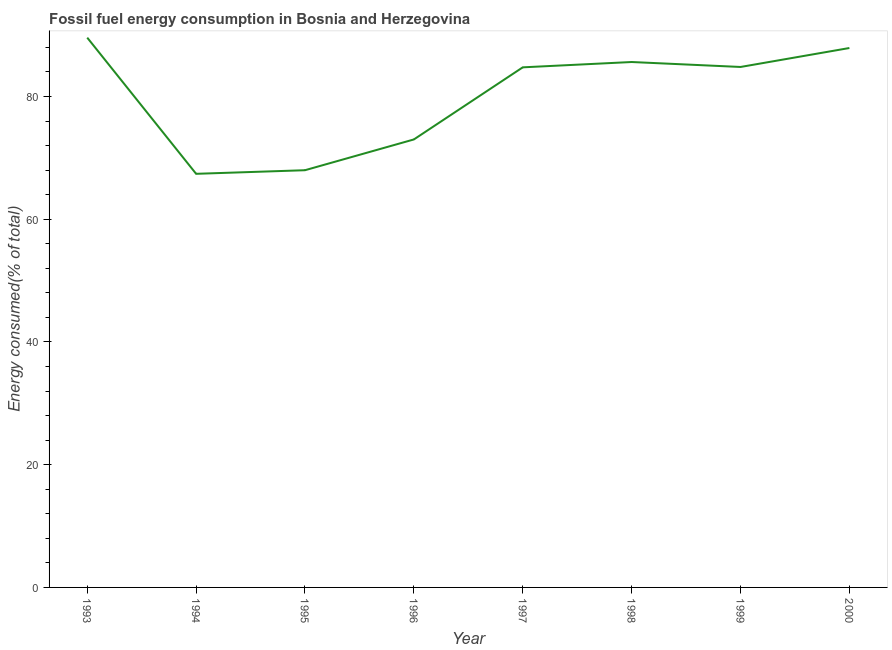What is the fossil fuel energy consumption in 2000?
Give a very brief answer. 87.89. Across all years, what is the maximum fossil fuel energy consumption?
Offer a very short reply. 89.58. Across all years, what is the minimum fossil fuel energy consumption?
Offer a terse response. 67.39. In which year was the fossil fuel energy consumption maximum?
Provide a succinct answer. 1993. In which year was the fossil fuel energy consumption minimum?
Provide a succinct answer. 1994. What is the sum of the fossil fuel energy consumption?
Your answer should be very brief. 641.01. What is the difference between the fossil fuel energy consumption in 1995 and 1996?
Offer a terse response. -5.01. What is the average fossil fuel energy consumption per year?
Provide a short and direct response. 80.13. What is the median fossil fuel energy consumption?
Make the answer very short. 84.78. Do a majority of the years between 1998 and 2000 (inclusive) have fossil fuel energy consumption greater than 20 %?
Give a very brief answer. Yes. What is the ratio of the fossil fuel energy consumption in 1996 to that in 1999?
Offer a very short reply. 0.86. What is the difference between the highest and the second highest fossil fuel energy consumption?
Keep it short and to the point. 1.69. Is the sum of the fossil fuel energy consumption in 1993 and 1994 greater than the maximum fossil fuel energy consumption across all years?
Your answer should be very brief. Yes. What is the difference between the highest and the lowest fossil fuel energy consumption?
Ensure brevity in your answer.  22.19. In how many years, is the fossil fuel energy consumption greater than the average fossil fuel energy consumption taken over all years?
Make the answer very short. 5. Does the fossil fuel energy consumption monotonically increase over the years?
Give a very brief answer. No. Does the graph contain grids?
Offer a terse response. No. What is the title of the graph?
Provide a succinct answer. Fossil fuel energy consumption in Bosnia and Herzegovina. What is the label or title of the Y-axis?
Your answer should be compact. Energy consumed(% of total). What is the Energy consumed(% of total) of 1993?
Your answer should be compact. 89.58. What is the Energy consumed(% of total) in 1994?
Make the answer very short. 67.39. What is the Energy consumed(% of total) of 1995?
Keep it short and to the point. 67.98. What is the Energy consumed(% of total) in 1996?
Provide a succinct answer. 72.99. What is the Energy consumed(% of total) in 1997?
Provide a succinct answer. 84.75. What is the Energy consumed(% of total) in 1998?
Keep it short and to the point. 85.61. What is the Energy consumed(% of total) of 1999?
Ensure brevity in your answer.  84.8. What is the Energy consumed(% of total) of 2000?
Your answer should be compact. 87.89. What is the difference between the Energy consumed(% of total) in 1993 and 1994?
Your answer should be very brief. 22.19. What is the difference between the Energy consumed(% of total) in 1993 and 1995?
Your answer should be compact. 21.6. What is the difference between the Energy consumed(% of total) in 1993 and 1996?
Provide a short and direct response. 16.59. What is the difference between the Energy consumed(% of total) in 1993 and 1997?
Your response must be concise. 4.84. What is the difference between the Energy consumed(% of total) in 1993 and 1998?
Your response must be concise. 3.97. What is the difference between the Energy consumed(% of total) in 1993 and 1999?
Ensure brevity in your answer.  4.78. What is the difference between the Energy consumed(% of total) in 1993 and 2000?
Ensure brevity in your answer.  1.69. What is the difference between the Energy consumed(% of total) in 1994 and 1995?
Provide a succinct answer. -0.59. What is the difference between the Energy consumed(% of total) in 1994 and 1996?
Offer a very short reply. -5.6. What is the difference between the Energy consumed(% of total) in 1994 and 1997?
Make the answer very short. -17.35. What is the difference between the Energy consumed(% of total) in 1994 and 1998?
Keep it short and to the point. -18.22. What is the difference between the Energy consumed(% of total) in 1994 and 1999?
Give a very brief answer. -17.41. What is the difference between the Energy consumed(% of total) in 1994 and 2000?
Your answer should be very brief. -20.5. What is the difference between the Energy consumed(% of total) in 1995 and 1996?
Keep it short and to the point. -5.01. What is the difference between the Energy consumed(% of total) in 1995 and 1997?
Provide a succinct answer. -16.76. What is the difference between the Energy consumed(% of total) in 1995 and 1998?
Your response must be concise. -17.63. What is the difference between the Energy consumed(% of total) in 1995 and 1999?
Give a very brief answer. -16.82. What is the difference between the Energy consumed(% of total) in 1995 and 2000?
Make the answer very short. -19.91. What is the difference between the Energy consumed(% of total) in 1996 and 1997?
Your response must be concise. -11.75. What is the difference between the Energy consumed(% of total) in 1996 and 1998?
Provide a short and direct response. -12.62. What is the difference between the Energy consumed(% of total) in 1996 and 1999?
Keep it short and to the point. -11.81. What is the difference between the Energy consumed(% of total) in 1996 and 2000?
Provide a succinct answer. -14.9. What is the difference between the Energy consumed(% of total) in 1997 and 1998?
Make the answer very short. -0.87. What is the difference between the Energy consumed(% of total) in 1997 and 1999?
Your answer should be compact. -0.06. What is the difference between the Energy consumed(% of total) in 1997 and 2000?
Offer a terse response. -3.15. What is the difference between the Energy consumed(% of total) in 1998 and 1999?
Your response must be concise. 0.81. What is the difference between the Energy consumed(% of total) in 1998 and 2000?
Provide a short and direct response. -2.28. What is the difference between the Energy consumed(% of total) in 1999 and 2000?
Give a very brief answer. -3.09. What is the ratio of the Energy consumed(% of total) in 1993 to that in 1994?
Provide a succinct answer. 1.33. What is the ratio of the Energy consumed(% of total) in 1993 to that in 1995?
Keep it short and to the point. 1.32. What is the ratio of the Energy consumed(% of total) in 1993 to that in 1996?
Ensure brevity in your answer.  1.23. What is the ratio of the Energy consumed(% of total) in 1993 to that in 1997?
Make the answer very short. 1.06. What is the ratio of the Energy consumed(% of total) in 1993 to that in 1998?
Your answer should be very brief. 1.05. What is the ratio of the Energy consumed(% of total) in 1993 to that in 1999?
Keep it short and to the point. 1.06. What is the ratio of the Energy consumed(% of total) in 1993 to that in 2000?
Provide a short and direct response. 1.02. What is the ratio of the Energy consumed(% of total) in 1994 to that in 1995?
Offer a terse response. 0.99. What is the ratio of the Energy consumed(% of total) in 1994 to that in 1996?
Your answer should be compact. 0.92. What is the ratio of the Energy consumed(% of total) in 1994 to that in 1997?
Provide a succinct answer. 0.8. What is the ratio of the Energy consumed(% of total) in 1994 to that in 1998?
Offer a terse response. 0.79. What is the ratio of the Energy consumed(% of total) in 1994 to that in 1999?
Provide a succinct answer. 0.8. What is the ratio of the Energy consumed(% of total) in 1994 to that in 2000?
Your answer should be very brief. 0.77. What is the ratio of the Energy consumed(% of total) in 1995 to that in 1997?
Offer a terse response. 0.8. What is the ratio of the Energy consumed(% of total) in 1995 to that in 1998?
Ensure brevity in your answer.  0.79. What is the ratio of the Energy consumed(% of total) in 1995 to that in 1999?
Your answer should be very brief. 0.8. What is the ratio of the Energy consumed(% of total) in 1995 to that in 2000?
Provide a short and direct response. 0.77. What is the ratio of the Energy consumed(% of total) in 1996 to that in 1997?
Your answer should be very brief. 0.86. What is the ratio of the Energy consumed(% of total) in 1996 to that in 1998?
Give a very brief answer. 0.85. What is the ratio of the Energy consumed(% of total) in 1996 to that in 1999?
Keep it short and to the point. 0.86. What is the ratio of the Energy consumed(% of total) in 1996 to that in 2000?
Provide a short and direct response. 0.83. What is the ratio of the Energy consumed(% of total) in 1997 to that in 2000?
Your response must be concise. 0.96. What is the ratio of the Energy consumed(% of total) in 1998 to that in 1999?
Your answer should be very brief. 1.01. What is the ratio of the Energy consumed(% of total) in 1999 to that in 2000?
Make the answer very short. 0.96. 